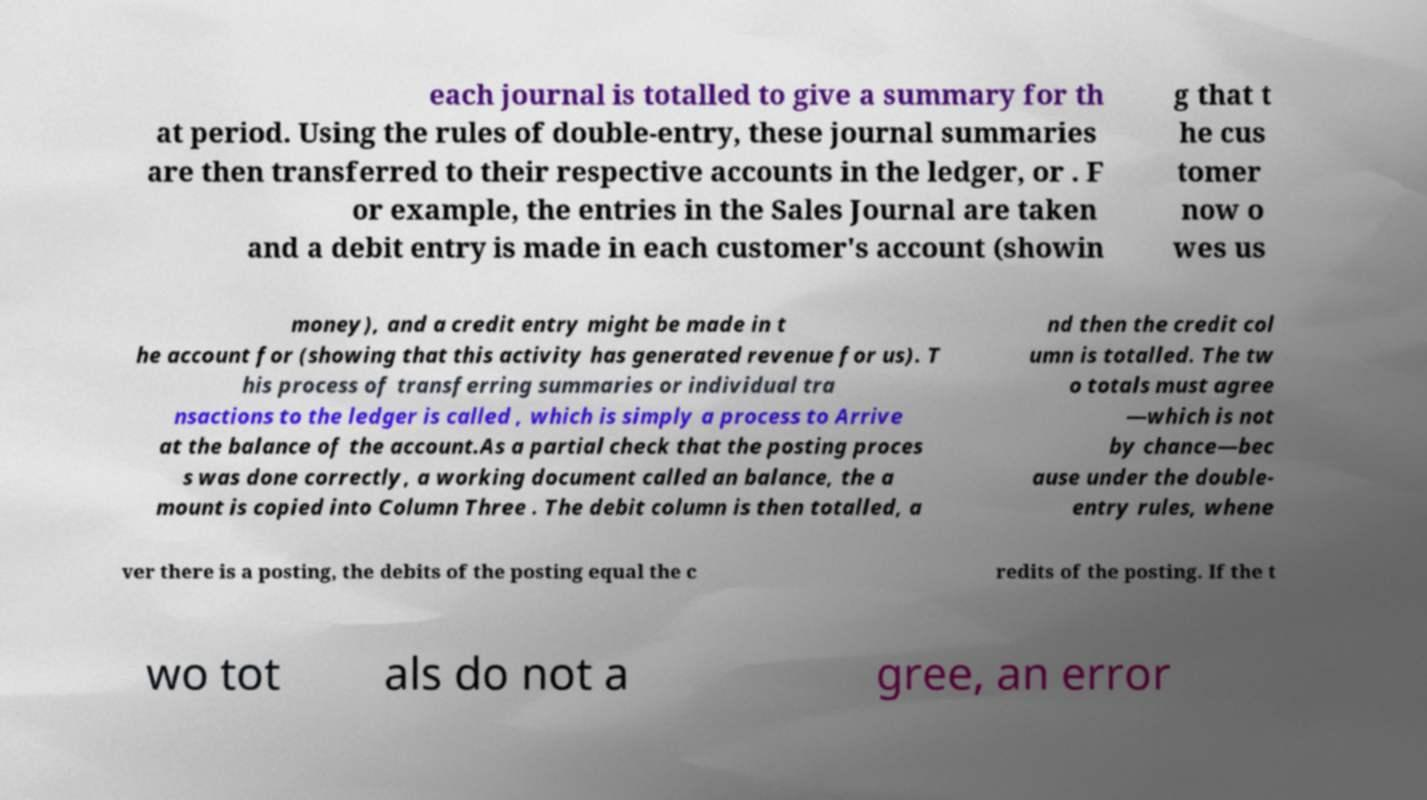Can you read and provide the text displayed in the image?This photo seems to have some interesting text. Can you extract and type it out for me? each journal is totalled to give a summary for th at period. Using the rules of double-entry, these journal summaries are then transferred to their respective accounts in the ledger, or . F or example, the entries in the Sales Journal are taken and a debit entry is made in each customer's account (showin g that t he cus tomer now o wes us money), and a credit entry might be made in t he account for (showing that this activity has generated revenue for us). T his process of transferring summaries or individual tra nsactions to the ledger is called , which is simply a process to Arrive at the balance of the account.As a partial check that the posting proces s was done correctly, a working document called an balance, the a mount is copied into Column Three . The debit column is then totalled, a nd then the credit col umn is totalled. The tw o totals must agree —which is not by chance—bec ause under the double- entry rules, whene ver there is a posting, the debits of the posting equal the c redits of the posting. If the t wo tot als do not a gree, an error 